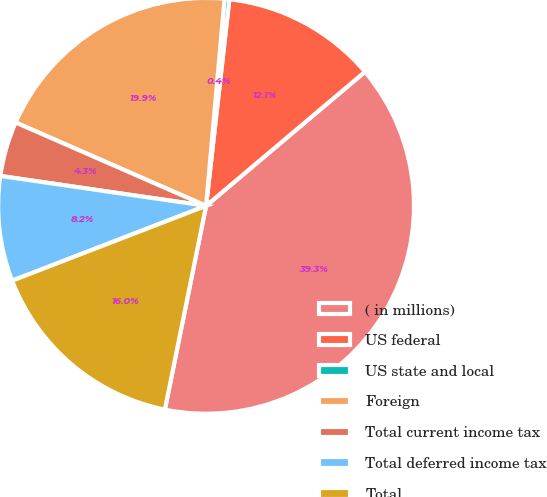Convert chart. <chart><loc_0><loc_0><loc_500><loc_500><pie_chart><fcel>( in millions)<fcel>US federal<fcel>US state and local<fcel>Foreign<fcel>Total current income tax<fcel>Total deferred income tax<fcel>Total<nl><fcel>39.33%<fcel>12.06%<fcel>0.37%<fcel>19.85%<fcel>4.27%<fcel>8.16%<fcel>15.96%<nl></chart> 